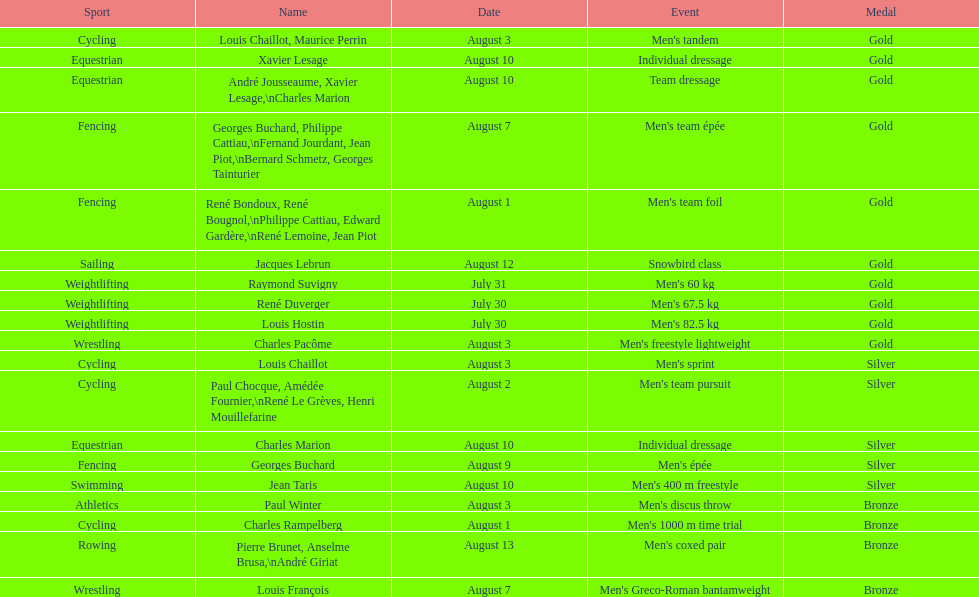Would you mind parsing the complete table? {'header': ['Sport', 'Name', 'Date', 'Event', 'Medal'], 'rows': [['Cycling', 'Louis Chaillot, Maurice Perrin', 'August 3', "Men's tandem", 'Gold'], ['Equestrian', 'Xavier Lesage', 'August 10', 'Individual dressage', 'Gold'], ['Equestrian', 'André Jousseaume, Xavier Lesage,\\nCharles Marion', 'August 10', 'Team dressage', 'Gold'], ['Fencing', 'Georges Buchard, Philippe Cattiau,\\nFernand Jourdant, Jean Piot,\\nBernard Schmetz, Georges Tainturier', 'August 7', "Men's team épée", 'Gold'], ['Fencing', 'René Bondoux, René Bougnol,\\nPhilippe Cattiau, Edward Gardère,\\nRené Lemoine, Jean Piot', 'August 1', "Men's team foil", 'Gold'], ['Sailing', 'Jacques Lebrun', 'August 12', 'Snowbird class', 'Gold'], ['Weightlifting', 'Raymond Suvigny', 'July 31', "Men's 60 kg", 'Gold'], ['Weightlifting', 'René Duverger', 'July 30', "Men's 67.5 kg", 'Gold'], ['Weightlifting', 'Louis Hostin', 'July 30', "Men's 82.5 kg", 'Gold'], ['Wrestling', 'Charles Pacôme', 'August 3', "Men's freestyle lightweight", 'Gold'], ['Cycling', 'Louis Chaillot', 'August 3', "Men's sprint", 'Silver'], ['Cycling', 'Paul Chocque, Amédée Fournier,\\nRené Le Grèves, Henri Mouillefarine', 'August 2', "Men's team pursuit", 'Silver'], ['Equestrian', 'Charles Marion', 'August 10', 'Individual dressage', 'Silver'], ['Fencing', 'Georges Buchard', 'August 9', "Men's épée", 'Silver'], ['Swimming', 'Jean Taris', 'August 10', "Men's 400 m freestyle", 'Silver'], ['Athletics', 'Paul Winter', 'August 3', "Men's discus throw", 'Bronze'], ['Cycling', 'Charles Rampelberg', 'August 1', "Men's 1000 m time trial", 'Bronze'], ['Rowing', 'Pierre Brunet, Anselme Brusa,\\nAndré Giriat', 'August 13', "Men's coxed pair", 'Bronze'], ['Wrestling', 'Louis François', 'August 7', "Men's Greco-Roman bantamweight", 'Bronze']]} How many total gold medals were won by weightlifting? 3. 